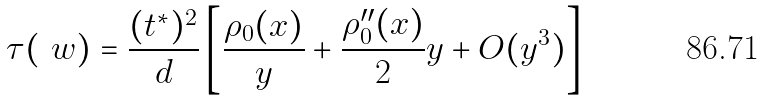<formula> <loc_0><loc_0><loc_500><loc_500>\tau ( \ w ) = \frac { ( t ^ { * } ) ^ { 2 } } { d } \left [ \frac { \rho _ { 0 } ( x ) } { y } + \frac { \rho _ { 0 } ^ { \prime \prime } ( x ) } { 2 } y + O ( y ^ { 3 } ) \right ]</formula> 